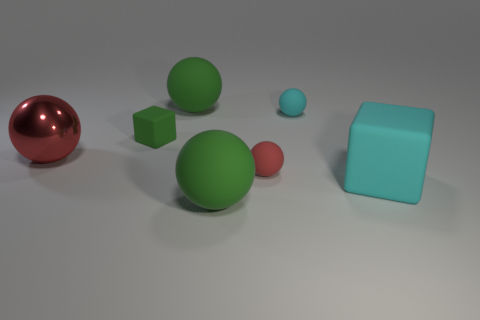What size is the thing that is the same color as the large rubber block?
Provide a succinct answer. Small. Is there anything else that has the same material as the large red ball?
Your answer should be very brief. No. There is a tiny green thing that is the same shape as the large cyan rubber thing; what is its material?
Provide a short and direct response. Rubber. Do the tiny cube and the large red ball have the same material?
Offer a very short reply. No. There is a big rubber object in front of the cube that is in front of the red metal sphere; what is its color?
Give a very brief answer. Green. The cyan cube that is the same material as the small red ball is what size?
Ensure brevity in your answer.  Large. What number of other red objects are the same shape as the large red object?
Your response must be concise. 1. How many objects are tiny matte spheres in front of the small cyan object or rubber objects behind the tiny red matte ball?
Your response must be concise. 4. What number of green spheres are to the right of the cyan matte object in front of the metallic thing?
Offer a terse response. 0. There is a cyan object that is behind the big cyan cube; does it have the same shape as the small rubber object on the left side of the tiny red ball?
Offer a terse response. No. 